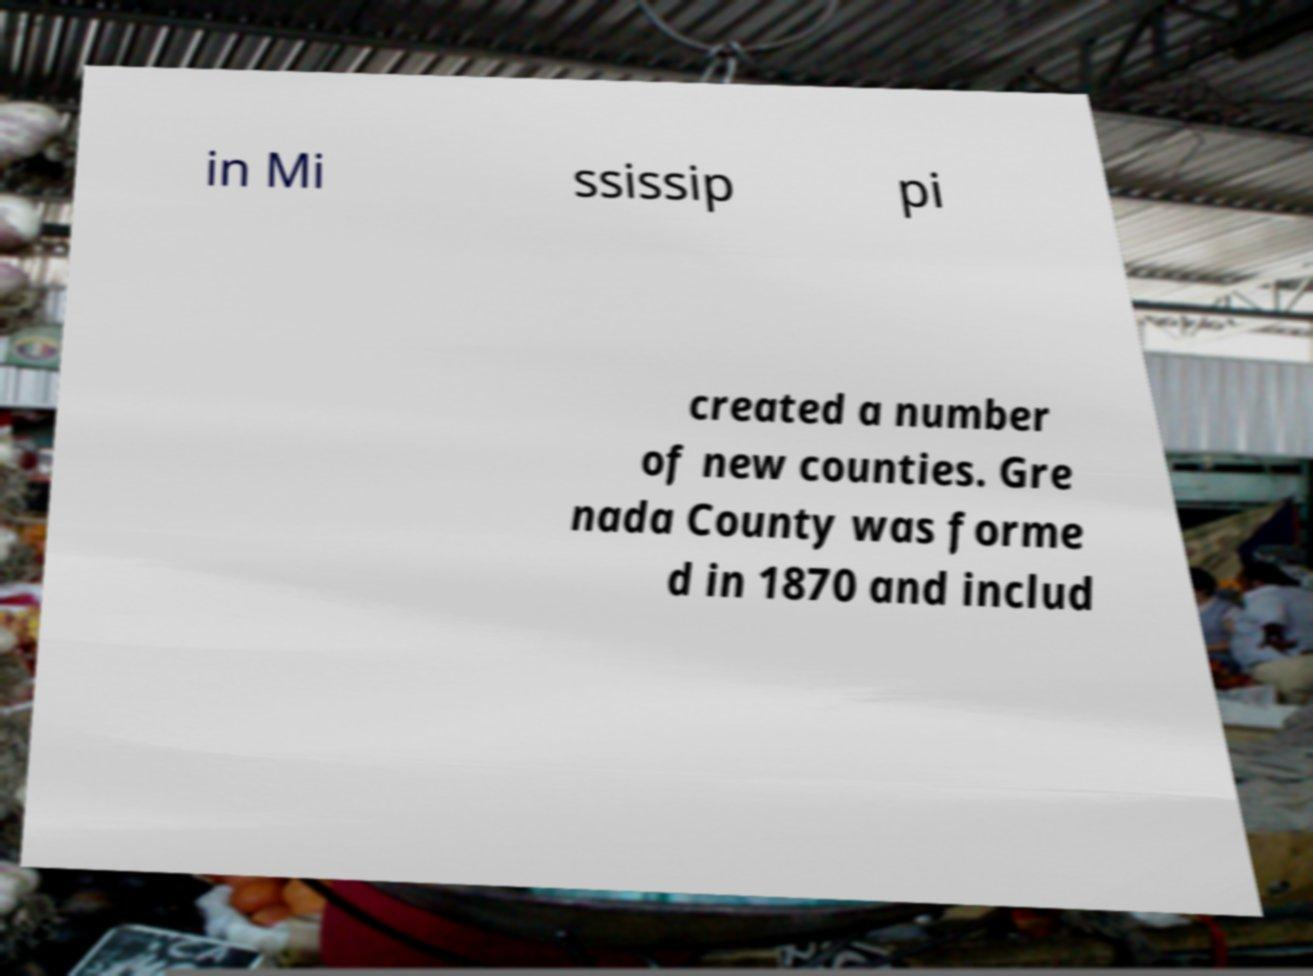Could you extract and type out the text from this image? in Mi ssissip pi created a number of new counties. Gre nada County was forme d in 1870 and includ 